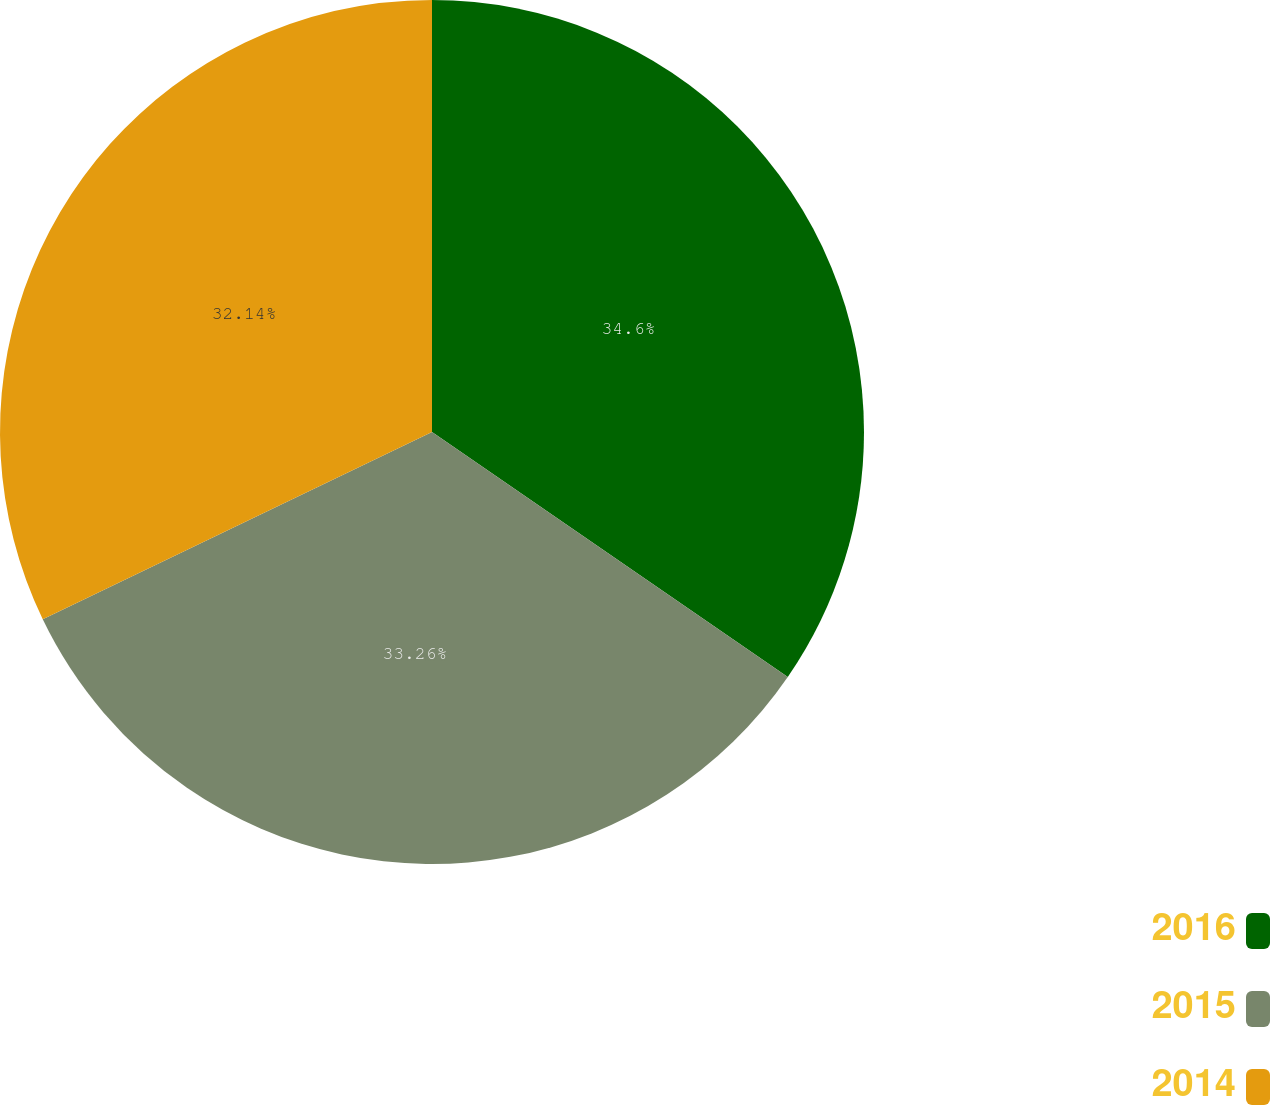Convert chart. <chart><loc_0><loc_0><loc_500><loc_500><pie_chart><fcel>2016<fcel>2015<fcel>2014<nl><fcel>34.6%<fcel>33.26%<fcel>32.14%<nl></chart> 